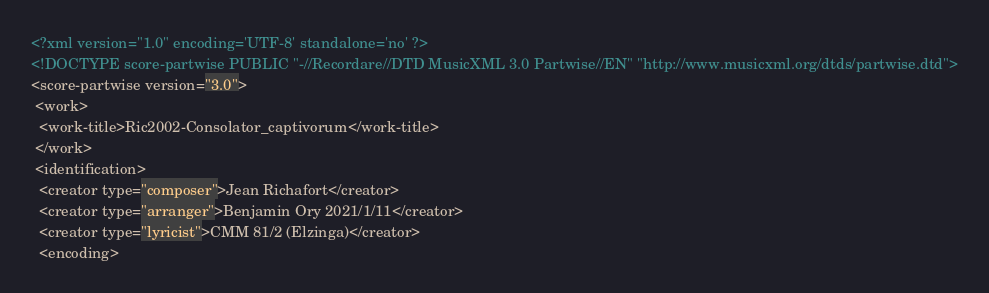<code> <loc_0><loc_0><loc_500><loc_500><_XML_><?xml version="1.0" encoding='UTF-8' standalone='no' ?>
<!DOCTYPE score-partwise PUBLIC "-//Recordare//DTD MusicXML 3.0 Partwise//EN" "http://www.musicxml.org/dtds/partwise.dtd">
<score-partwise version="3.0">
 <work>
  <work-title>Ric2002-Consolator_captivorum</work-title>
 </work>
 <identification>
  <creator type="composer">Jean Richafort</creator>
  <creator type="arranger">Benjamin Ory 2021/1/11</creator>
  <creator type="lyricist">CMM 81/2 (Elzinga)</creator>
  <encoding></code> 